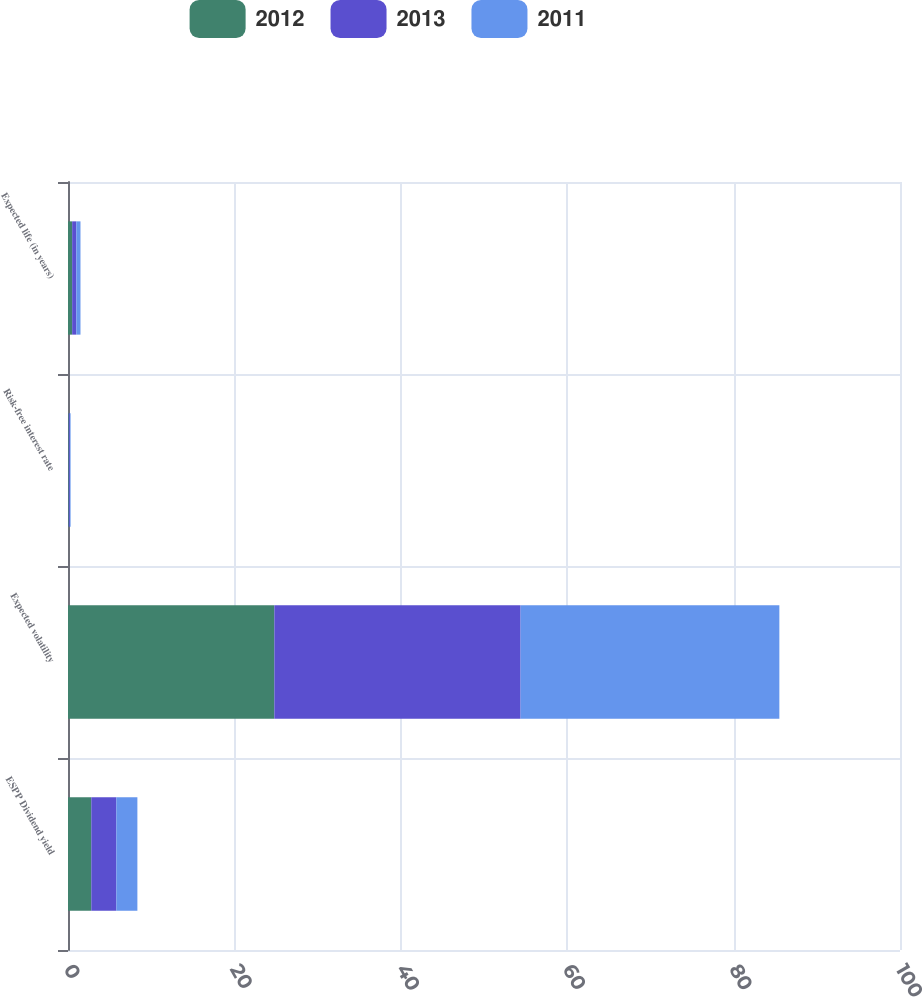Convert chart to OTSL. <chart><loc_0><loc_0><loc_500><loc_500><stacked_bar_chart><ecel><fcel>ESPP Dividend yield<fcel>Expected volatility<fcel>Risk-free interest rate<fcel>Expected life (in years)<nl><fcel>2012<fcel>2.8<fcel>24.8<fcel>0.09<fcel>0.5<nl><fcel>2013<fcel>3.01<fcel>29.6<fcel>0.13<fcel>0.5<nl><fcel>2011<fcel>2.53<fcel>31.1<fcel>0.09<fcel>0.5<nl></chart> 